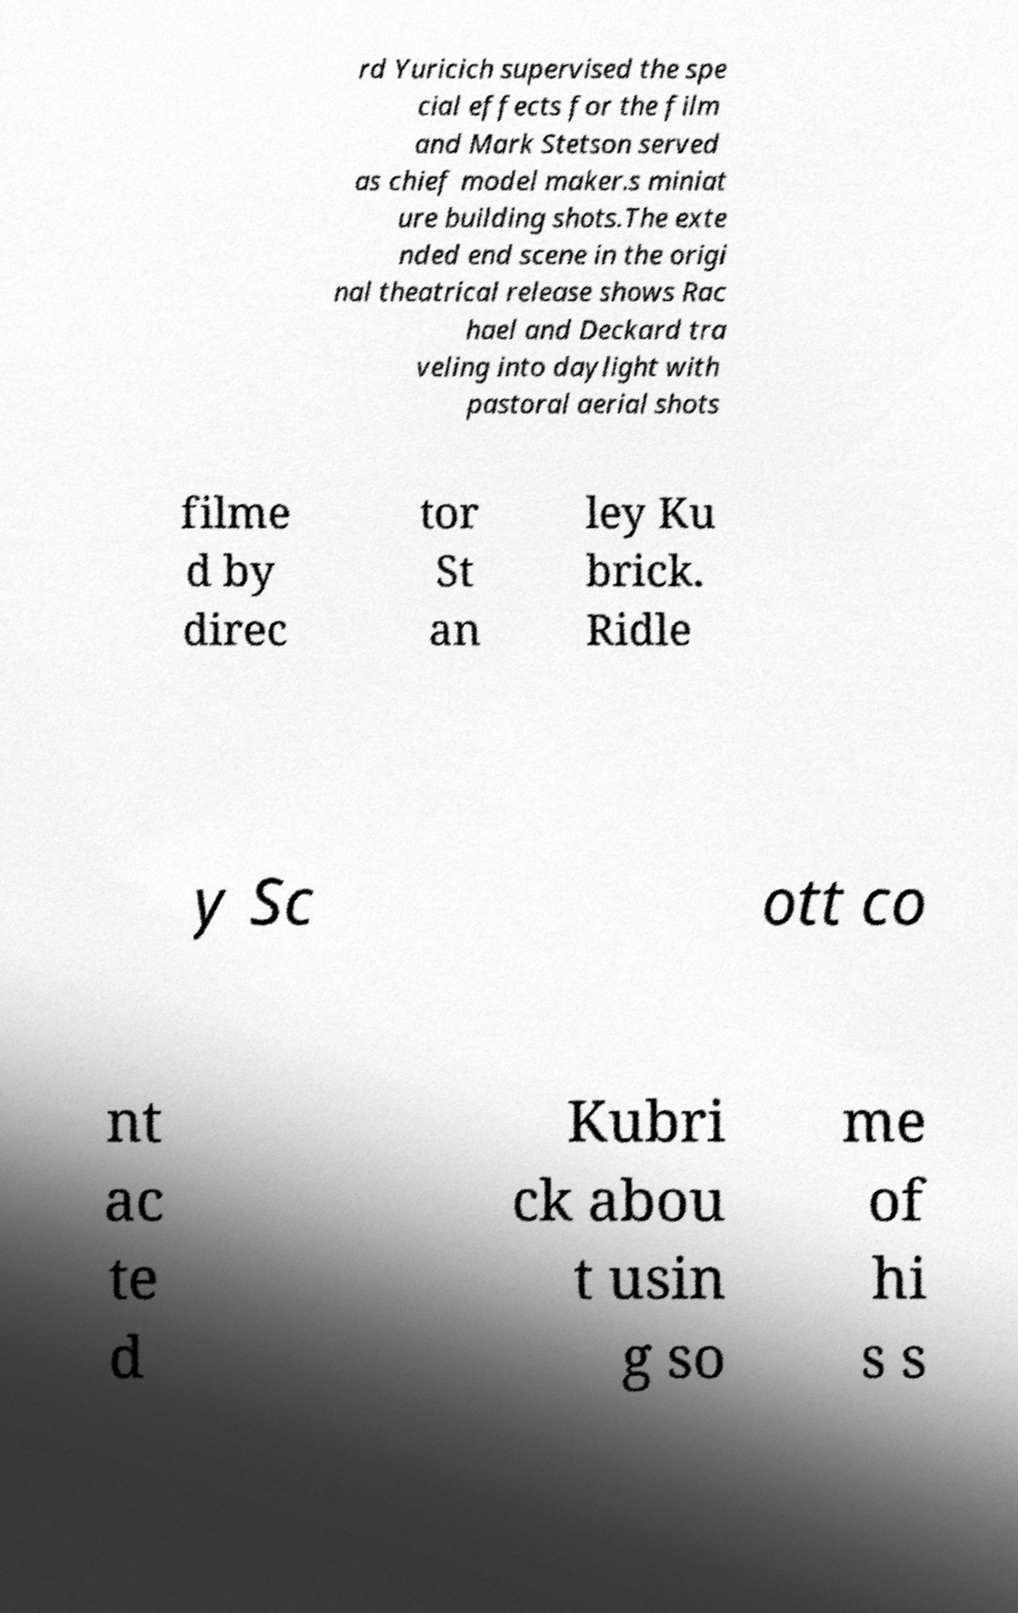For documentation purposes, I need the text within this image transcribed. Could you provide that? rd Yuricich supervised the spe cial effects for the film and Mark Stetson served as chief model maker.s miniat ure building shots.The exte nded end scene in the origi nal theatrical release shows Rac hael and Deckard tra veling into daylight with pastoral aerial shots filme d by direc tor St an ley Ku brick. Ridle y Sc ott co nt ac te d Kubri ck abou t usin g so me of hi s s 